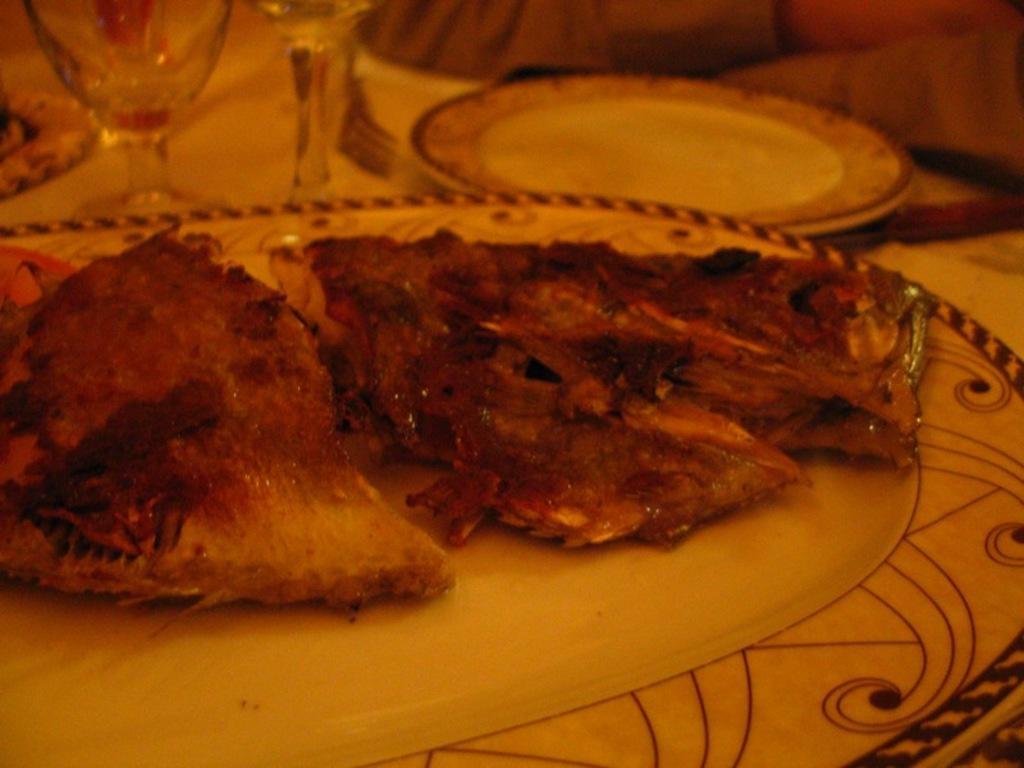In one or two sentences, can you explain what this image depicts? In this image I can see a table, plates, glasses, food, person hands and objects. 